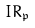<formula> <loc_0><loc_0><loc_500><loc_500>I R _ { \mathfrak { p } }</formula> 